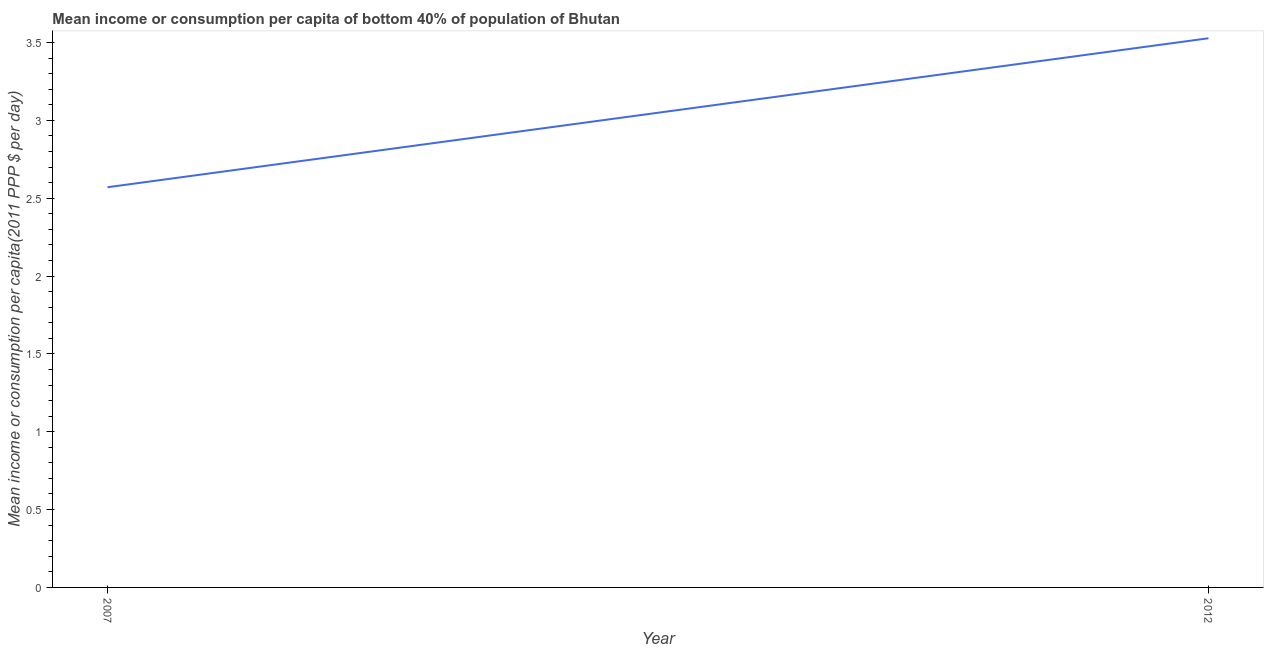What is the mean income or consumption in 2007?
Keep it short and to the point. 2.57. Across all years, what is the maximum mean income or consumption?
Give a very brief answer. 3.53. Across all years, what is the minimum mean income or consumption?
Make the answer very short. 2.57. In which year was the mean income or consumption minimum?
Your answer should be compact. 2007. What is the sum of the mean income or consumption?
Keep it short and to the point. 6.1. What is the difference between the mean income or consumption in 2007 and 2012?
Offer a terse response. -0.96. What is the average mean income or consumption per year?
Ensure brevity in your answer.  3.05. What is the median mean income or consumption?
Provide a short and direct response. 3.05. In how many years, is the mean income or consumption greater than 1.4 $?
Provide a succinct answer. 2. Do a majority of the years between 2012 and 2007 (inclusive) have mean income or consumption greater than 0.9 $?
Ensure brevity in your answer.  No. What is the ratio of the mean income or consumption in 2007 to that in 2012?
Provide a short and direct response. 0.73. Is the mean income or consumption in 2007 less than that in 2012?
Keep it short and to the point. Yes. How many lines are there?
Provide a short and direct response. 1. How many years are there in the graph?
Your answer should be compact. 2. Does the graph contain any zero values?
Provide a short and direct response. No. Does the graph contain grids?
Provide a succinct answer. No. What is the title of the graph?
Ensure brevity in your answer.  Mean income or consumption per capita of bottom 40% of population of Bhutan. What is the label or title of the Y-axis?
Your answer should be compact. Mean income or consumption per capita(2011 PPP $ per day). What is the Mean income or consumption per capita(2011 PPP $ per day) in 2007?
Provide a short and direct response. 2.57. What is the Mean income or consumption per capita(2011 PPP $ per day) of 2012?
Provide a succinct answer. 3.53. What is the difference between the Mean income or consumption per capita(2011 PPP $ per day) in 2007 and 2012?
Offer a terse response. -0.96. What is the ratio of the Mean income or consumption per capita(2011 PPP $ per day) in 2007 to that in 2012?
Provide a short and direct response. 0.73. 